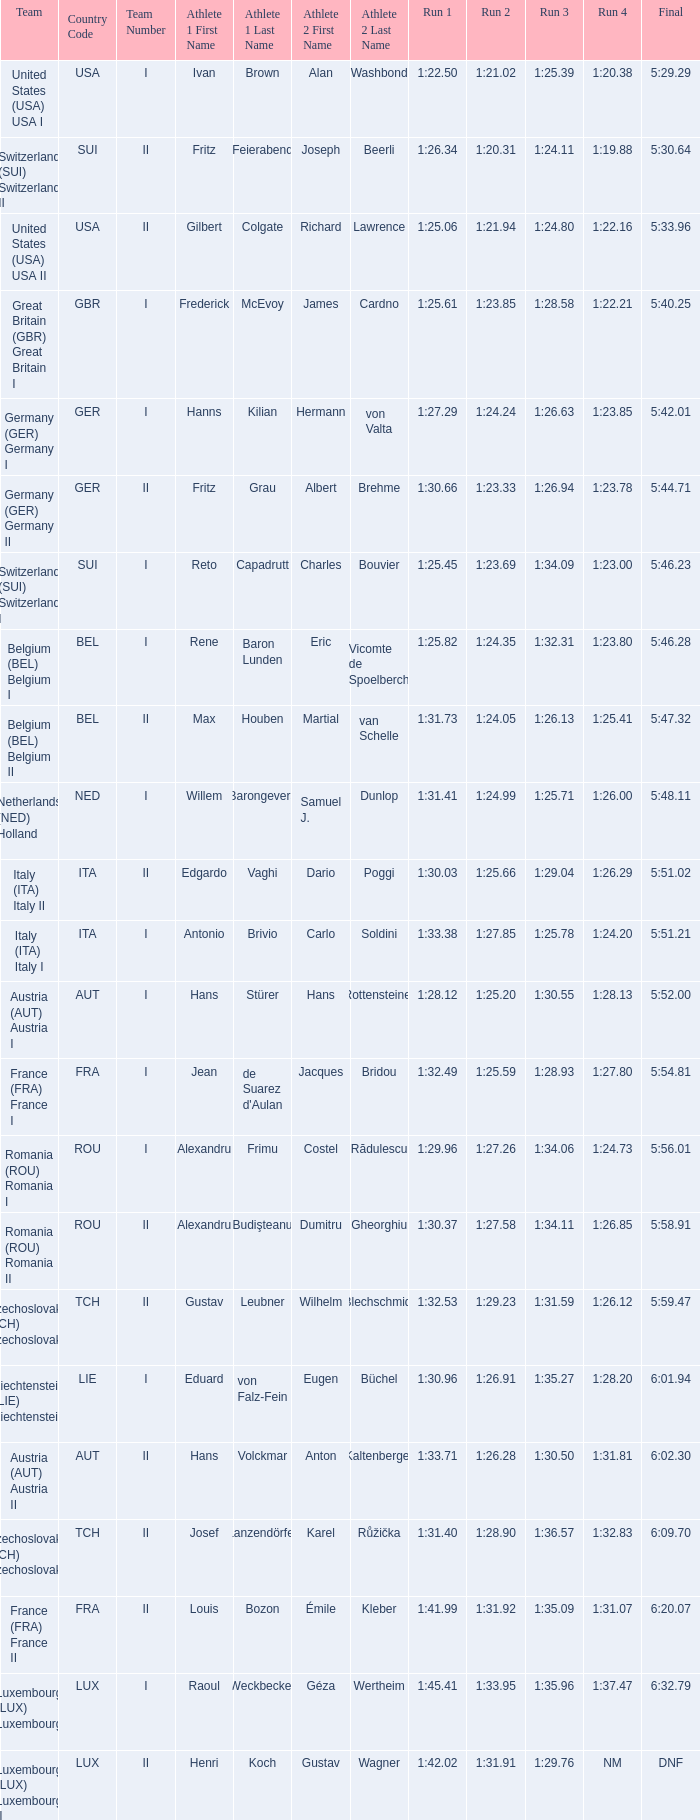Which Final has a Team of liechtenstein (lie) liechtenstein i? 6:01.94. 